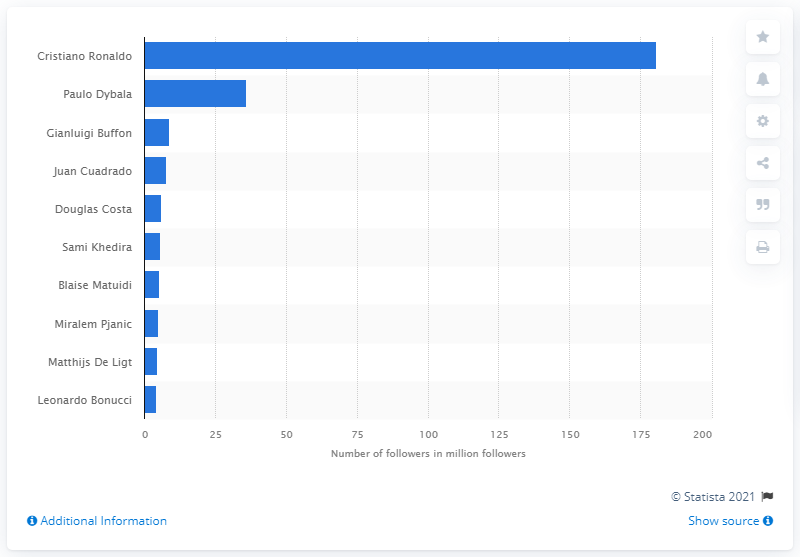Highlight a few significant elements in this photo. Paulo Dybala is the second most popular Juventus player on Instagram. According to the data available as of February 2020, Cristiano Ronaldo was the most popular Juventus player on Instagram. 